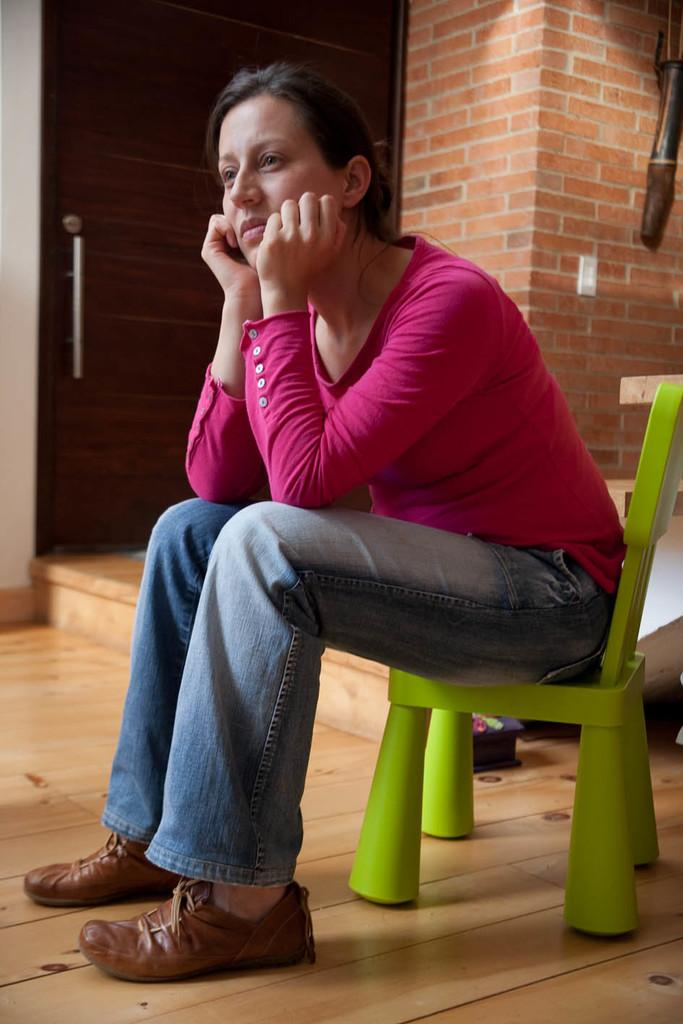Who is present in the image? There is a woman in the image. What is the woman wearing on her upper body? The woman is wearing a pink t-shirt. What type of pants is the woman wearing? The woman is wearing jeans. What type of footwear is the woman wearing? The woman is wearing shoes. What is the woman sitting on in the image? The woman is sitting on a green chair. What is the condition of the room in the image? The room is closed. What is a prominent feature in the room? There is a big brick wall in the room. What is a possible means of entering or exiting the room? There is a door present in the room. What type of whip is the woman using to teach in the image? There is no whip present in the image, nor is there any indication that the woman is teaching. 